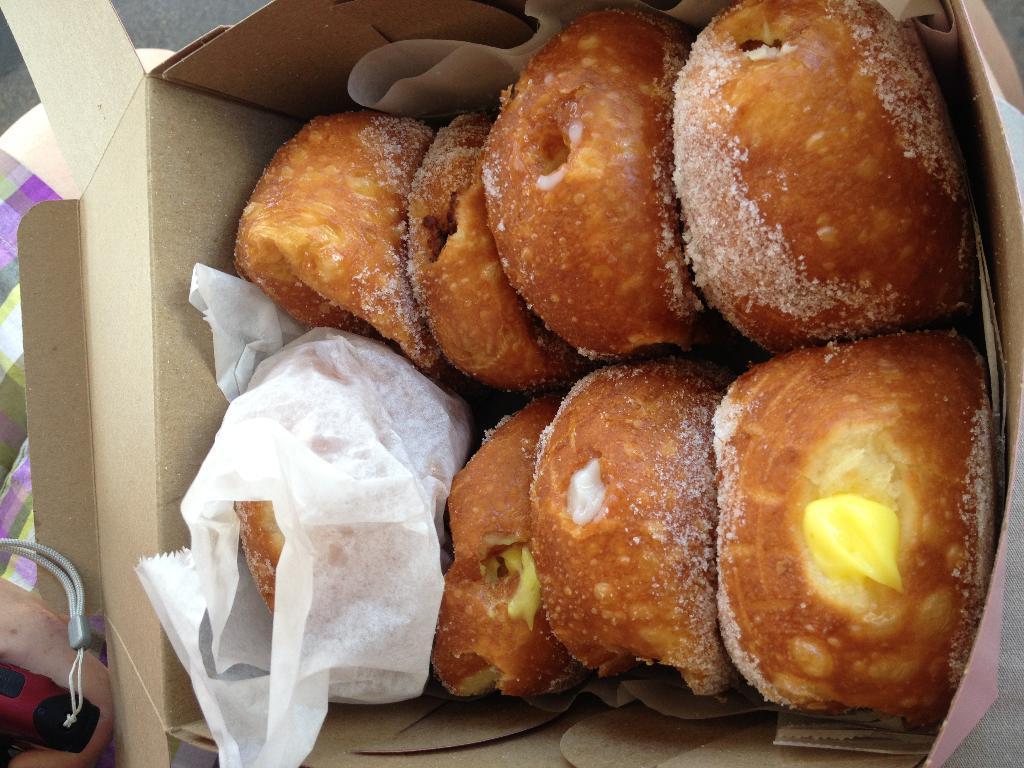Can you describe this image briefly? In this picture I can see there is a box and there is food placed in the box and it has some butter and sugar on it. The food is wrapped in a paper and in the backdrop I can see there is a grey surface and a napkin. 